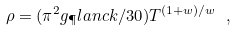<formula> <loc_0><loc_0><loc_500><loc_500>\rho = ( { \pi ^ { 2 } g _ { \P } l a n c k / 3 0 } ) T ^ { ( 1 + w ) / w } \ ,</formula> 